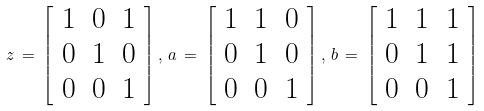Convert formula to latex. <formula><loc_0><loc_0><loc_500><loc_500>z \, = \, \left [ \begin{array} { c c c } 1 & 0 & 1 \\ 0 & 1 & 0 \\ 0 & 0 & 1 \end{array} \right ] , \, a \, = \, \left [ \begin{array} { c c c } 1 & 1 & 0 \\ 0 & 1 & 0 \\ 0 & 0 & 1 \end{array} \right ] , \, b \, = \, \left [ \begin{array} { c c c } 1 & 1 & 1 \\ 0 & 1 & 1 \\ 0 & 0 & 1 \end{array} \right ]</formula> 